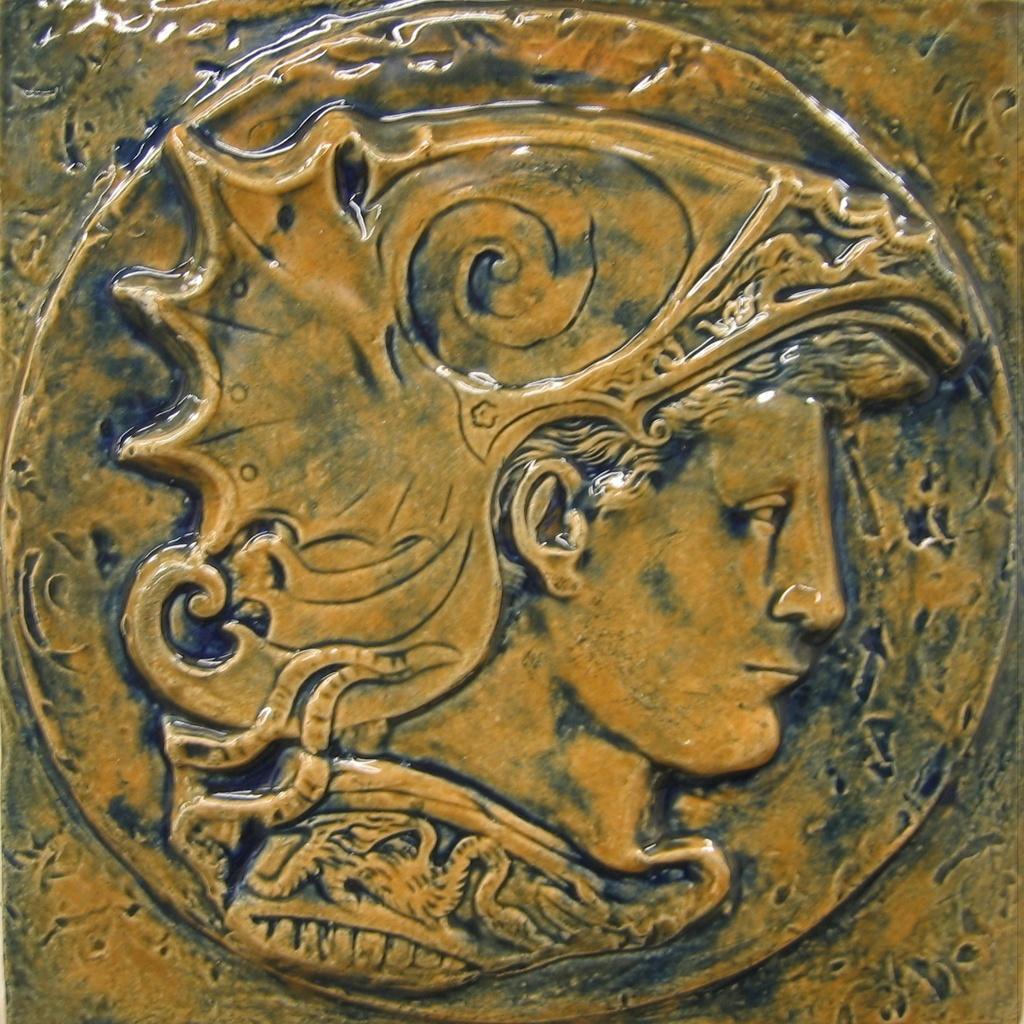Can you describe this image briefly? In the image in the center, we can see carving on the wall, in which we can see the human face. 